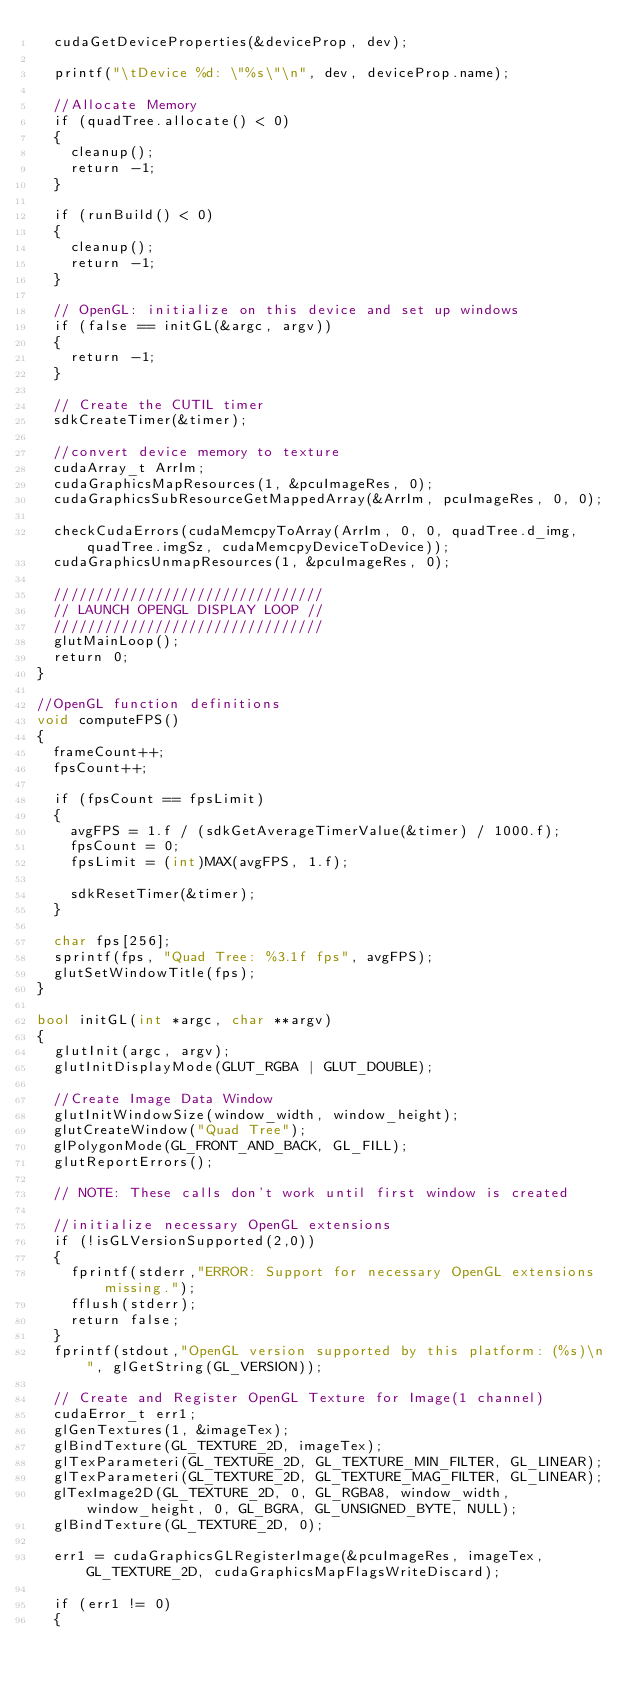<code> <loc_0><loc_0><loc_500><loc_500><_Cuda_>	cudaGetDeviceProperties(&deviceProp, dev);

	printf("\tDevice %d: \"%s\"\n", dev, deviceProp.name);

	//Allocate Memory
	if (quadTree.allocate() < 0)
	{
		cleanup();
		return -1;
	}

	if (runBuild() < 0)
	{
		cleanup();
		return -1;
	}

	// OpenGL: initialize on this device and set up windows
	if (false == initGL(&argc, argv))
	{
		return -1;
	}

	// Create the CUTIL timer
	sdkCreateTimer(&timer);

	//convert device memory to texture
	cudaArray_t ArrIm;
	cudaGraphicsMapResources(1, &pcuImageRes, 0);
	cudaGraphicsSubResourceGetMappedArray(&ArrIm, pcuImageRes, 0, 0);

	checkCudaErrors(cudaMemcpyToArray(ArrIm, 0, 0, quadTree.d_img, quadTree.imgSz, cudaMemcpyDeviceToDevice));
	cudaGraphicsUnmapResources(1, &pcuImageRes, 0);

	////////////////////////////////
	// LAUNCH OPENGL DISPLAY LOOP //
	////////////////////////////////
	glutMainLoop();
	return 0;
}

//OpenGL function definitions
void computeFPS()
{
	frameCount++;
	fpsCount++;

	if (fpsCount == fpsLimit)
	{
		avgFPS = 1.f / (sdkGetAverageTimerValue(&timer) / 1000.f);
		fpsCount = 0;
		fpsLimit = (int)MAX(avgFPS, 1.f);

		sdkResetTimer(&timer);
	}
	
	char fps[256];
	sprintf(fps, "Quad Tree: %3.1f fps", avgFPS);
	glutSetWindowTitle(fps);
}

bool initGL(int *argc, char **argv)
{
	glutInit(argc, argv);
	glutInitDisplayMode(GLUT_RGBA | GLUT_DOUBLE);

	//Create Image Data Window
	glutInitWindowSize(window_width, window_height);
	glutCreateWindow("Quad Tree");
	glPolygonMode(GL_FRONT_AND_BACK, GL_FILL);
	glutReportErrors();

	// NOTE: These calls don't work until first window is created

	//initialize necessary OpenGL extensions
	if (!isGLVersionSupported(2,0))
	{
		fprintf(stderr,"ERROR: Support for necessary OpenGL extensions missing.");
		fflush(stderr);
		return false;
	}
	fprintf(stdout,"OpenGL version supported by this platform: (%s)\n", glGetString(GL_VERSION));

	// Create and Register OpenGL Texture for Image(1 channel)
	cudaError_t err1;
	glGenTextures(1, &imageTex);
	glBindTexture(GL_TEXTURE_2D, imageTex);
	glTexParameteri(GL_TEXTURE_2D, GL_TEXTURE_MIN_FILTER, GL_LINEAR);
	glTexParameteri(GL_TEXTURE_2D, GL_TEXTURE_MAG_FILTER, GL_LINEAR);
	glTexImage2D(GL_TEXTURE_2D, 0, GL_RGBA8, window_width, window_height, 0, GL_BGRA, GL_UNSIGNED_BYTE, NULL);
	glBindTexture(GL_TEXTURE_2D, 0);

	err1 = cudaGraphicsGLRegisterImage(&pcuImageRes, imageTex, GL_TEXTURE_2D, cudaGraphicsMapFlagsWriteDiscard);

	if (err1 != 0)
	{</code> 